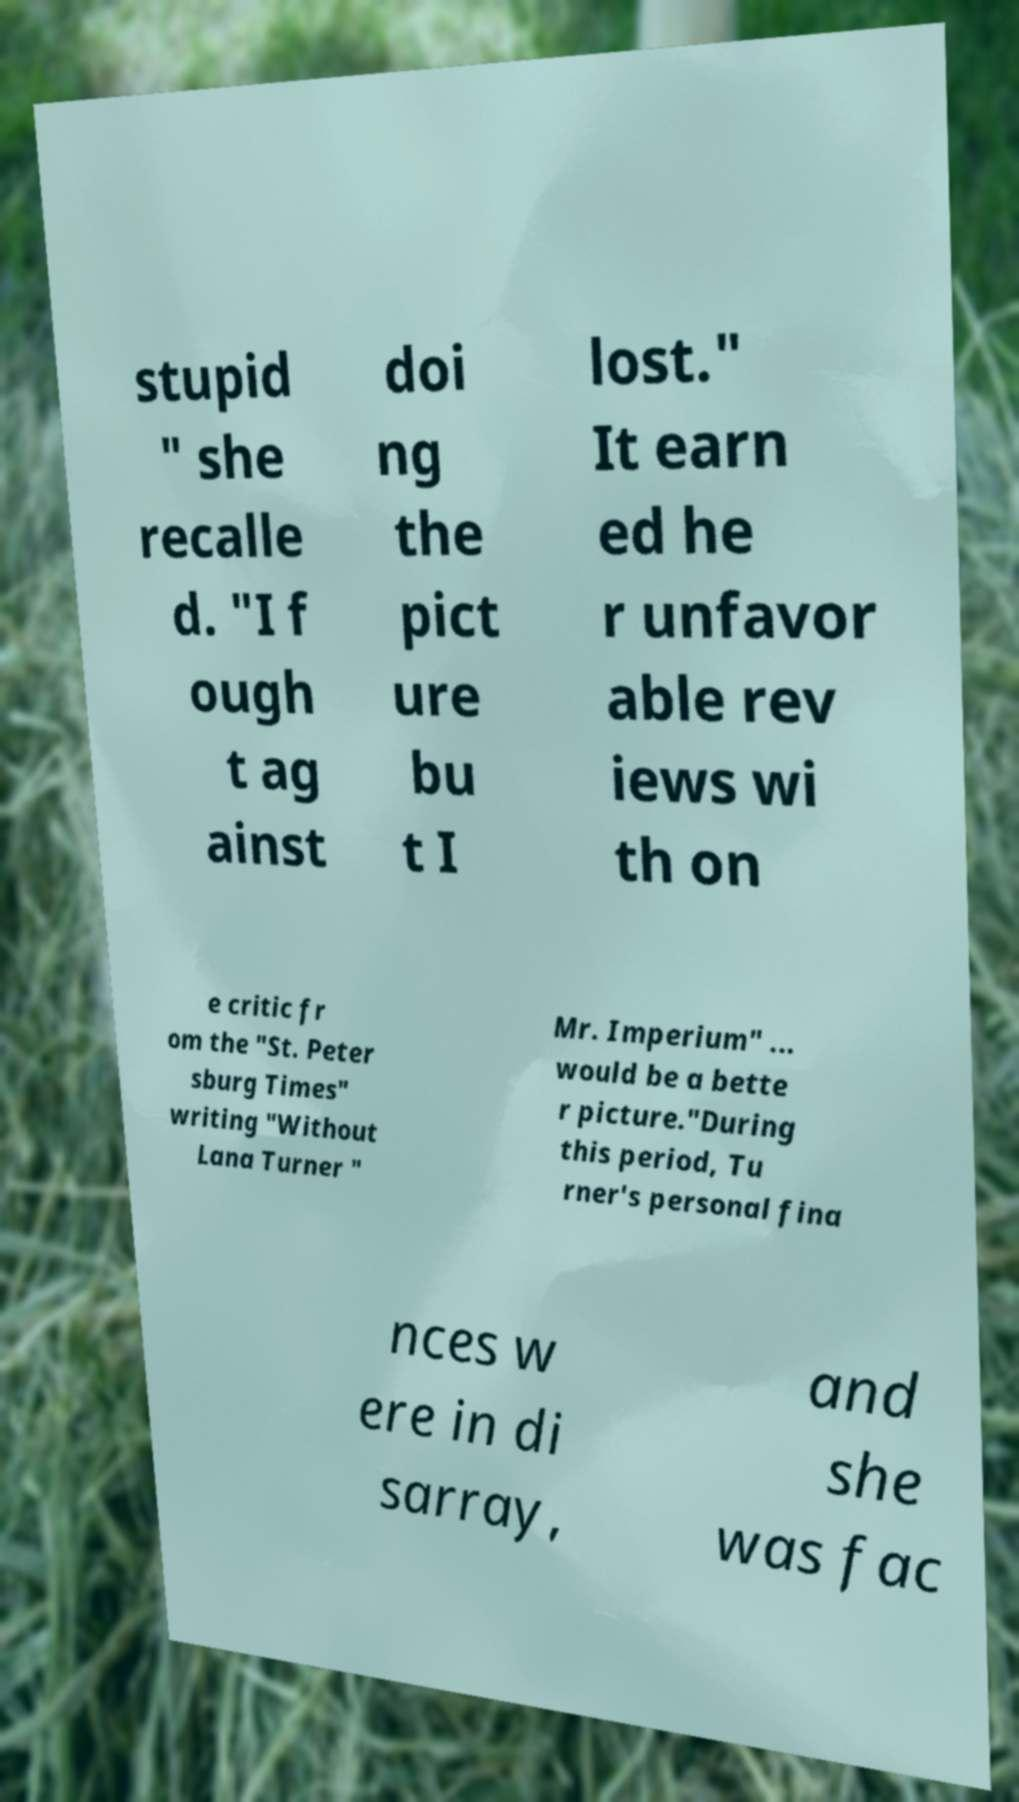Could you assist in decoding the text presented in this image and type it out clearly? stupid " she recalle d. "I f ough t ag ainst doi ng the pict ure bu t I lost." It earn ed he r unfavor able rev iews wi th on e critic fr om the "St. Peter sburg Times" writing "Without Lana Turner " Mr. Imperium" ... would be a bette r picture."During this period, Tu rner's personal fina nces w ere in di sarray, and she was fac 